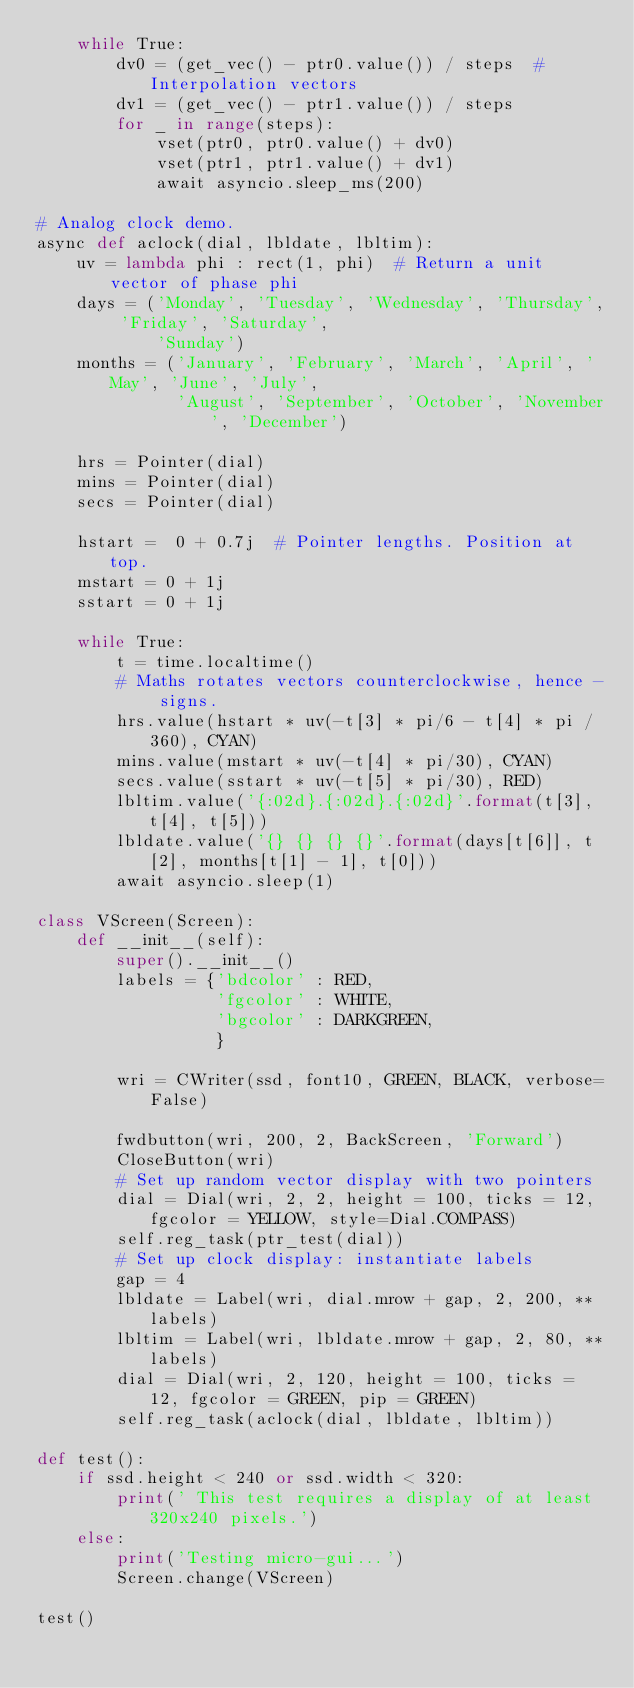<code> <loc_0><loc_0><loc_500><loc_500><_Python_>    while True:
        dv0 = (get_vec() - ptr0.value()) / steps  # Interpolation vectors
        dv1 = (get_vec() - ptr1.value()) / steps
        for _ in range(steps):
            vset(ptr0, ptr0.value() + dv0)
            vset(ptr1, ptr1.value() + dv1)
            await asyncio.sleep_ms(200)

# Analog clock demo.
async def aclock(dial, lbldate, lbltim):
    uv = lambda phi : rect(1, phi)  # Return a unit vector of phase phi
    days = ('Monday', 'Tuesday', 'Wednesday', 'Thursday', 'Friday', 'Saturday',
            'Sunday')
    months = ('January', 'February', 'March', 'April', 'May', 'June', 'July',
              'August', 'September', 'October', 'November', 'December')

    hrs = Pointer(dial)
    mins = Pointer(dial)
    secs = Pointer(dial)

    hstart =  0 + 0.7j  # Pointer lengths. Position at top.
    mstart = 0 + 1j
    sstart = 0 + 1j 

    while True:
        t = time.localtime()
        # Maths rotates vectors counterclockwise, hence - signs.
        hrs.value(hstart * uv(-t[3] * pi/6 - t[4] * pi / 360), CYAN)
        mins.value(mstart * uv(-t[4] * pi/30), CYAN)
        secs.value(sstart * uv(-t[5] * pi/30), RED)
        lbltim.value('{:02d}.{:02d}.{:02d}'.format(t[3], t[4], t[5]))
        lbldate.value('{} {} {} {}'.format(days[t[6]], t[2], months[t[1] - 1], t[0]))
        await asyncio.sleep(1)

class VScreen(Screen):
    def __init__(self):
        super().__init__()
        labels = {'bdcolor' : RED,
                  'fgcolor' : WHITE,
                  'bgcolor' : DARKGREEN,
                  }

        wri = CWriter(ssd, font10, GREEN, BLACK, verbose=False)

        fwdbutton(wri, 200, 2, BackScreen, 'Forward')
        CloseButton(wri)
        # Set up random vector display with two pointers
        dial = Dial(wri, 2, 2, height = 100, ticks = 12, fgcolor = YELLOW, style=Dial.COMPASS)
        self.reg_task(ptr_test(dial))
        # Set up clock display: instantiate labels
        gap = 4
        lbldate = Label(wri, dial.mrow + gap, 2, 200, **labels)
        lbltim = Label(wri, lbldate.mrow + gap, 2, 80, **labels)
        dial = Dial(wri, 2, 120, height = 100, ticks = 12, fgcolor = GREEN, pip = GREEN)
        self.reg_task(aclock(dial, lbldate, lbltim))

def test():
    if ssd.height < 240 or ssd.width < 320:
        print(' This test requires a display of at least 320x240 pixels.')
    else:
        print('Testing micro-gui...')
        Screen.change(VScreen)

test()
</code> 